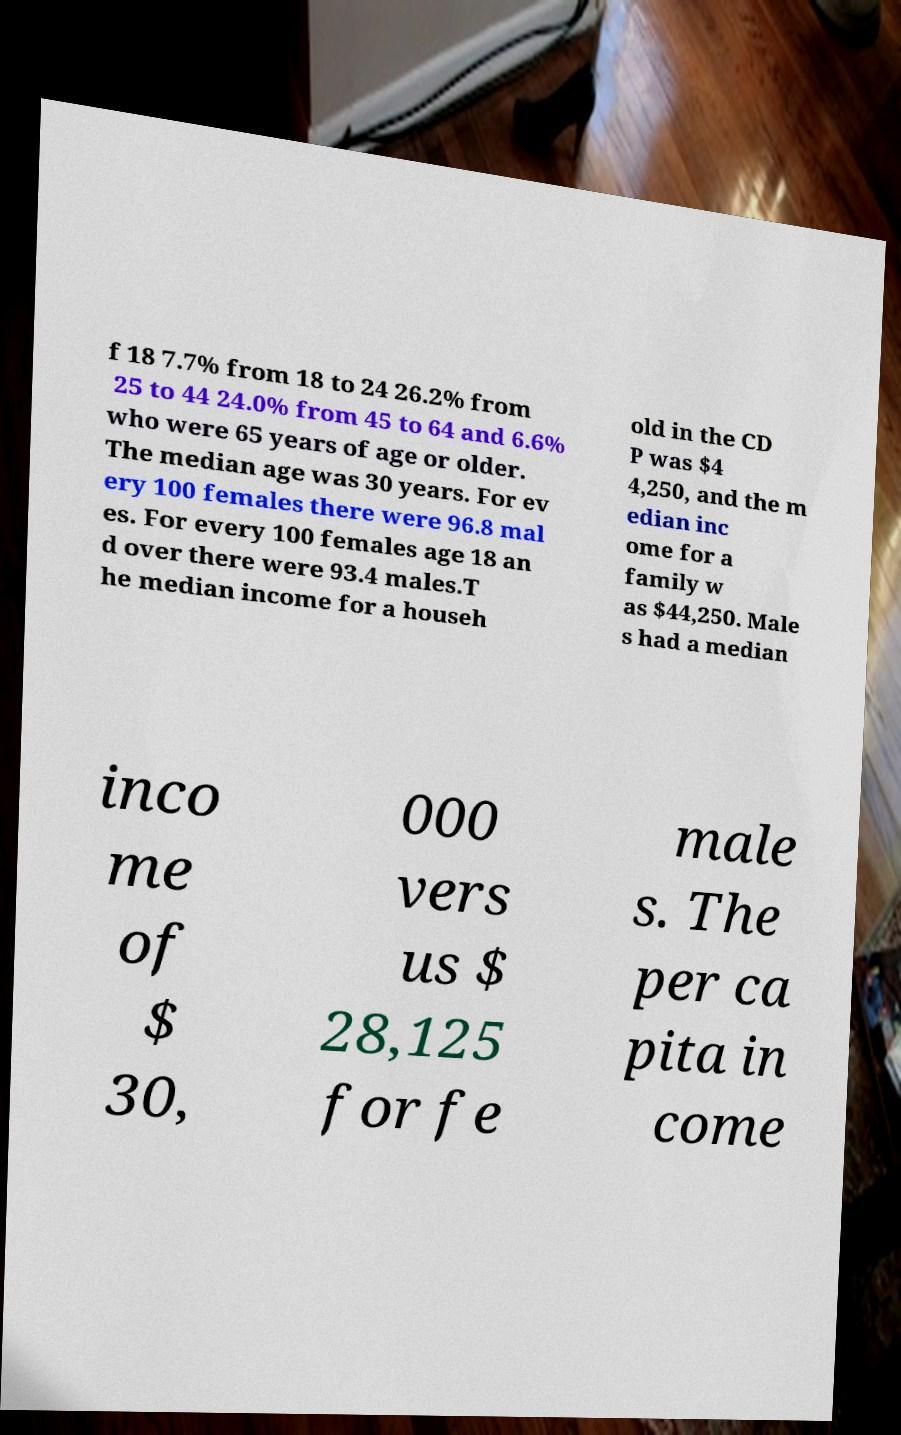Please read and relay the text visible in this image. What does it say? f 18 7.7% from 18 to 24 26.2% from 25 to 44 24.0% from 45 to 64 and 6.6% who were 65 years of age or older. The median age was 30 years. For ev ery 100 females there were 96.8 mal es. For every 100 females age 18 an d over there were 93.4 males.T he median income for a househ old in the CD P was $4 4,250, and the m edian inc ome for a family w as $44,250. Male s had a median inco me of $ 30, 000 vers us $ 28,125 for fe male s. The per ca pita in come 